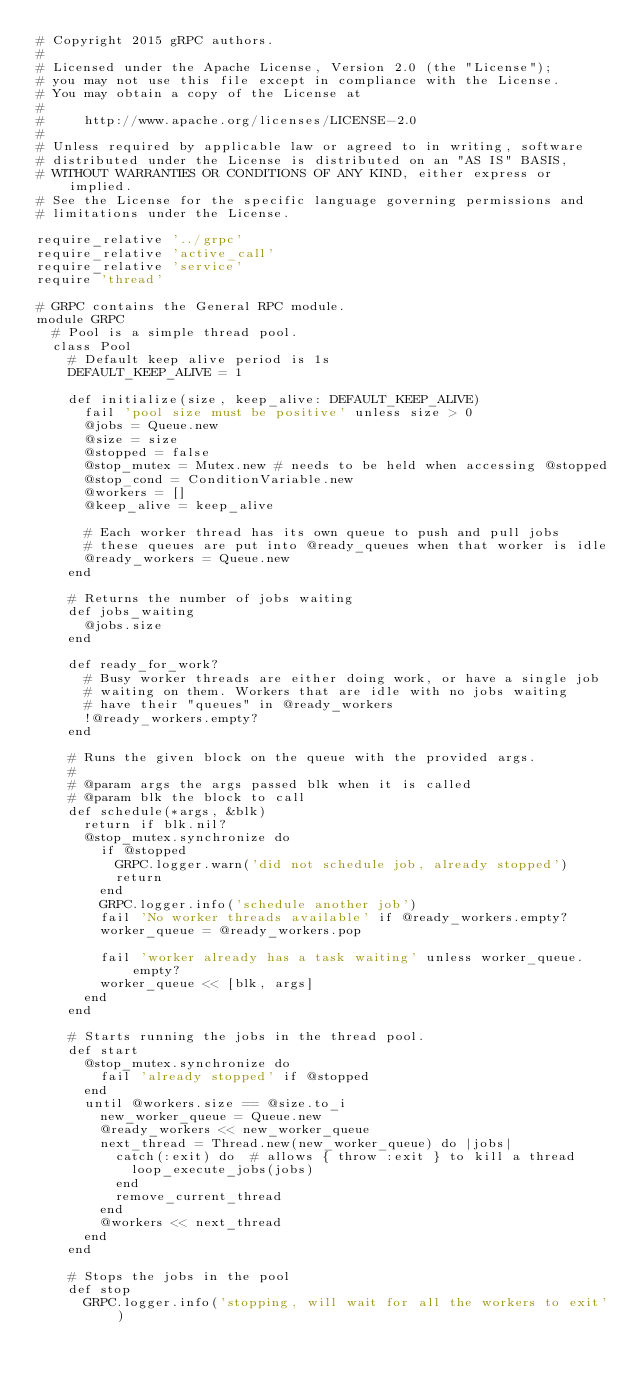<code> <loc_0><loc_0><loc_500><loc_500><_Ruby_># Copyright 2015 gRPC authors.
#
# Licensed under the Apache License, Version 2.0 (the "License");
# you may not use this file except in compliance with the License.
# You may obtain a copy of the License at
#
#     http://www.apache.org/licenses/LICENSE-2.0
#
# Unless required by applicable law or agreed to in writing, software
# distributed under the License is distributed on an "AS IS" BASIS,
# WITHOUT WARRANTIES OR CONDITIONS OF ANY KIND, either express or implied.
# See the License for the specific language governing permissions and
# limitations under the License.

require_relative '../grpc'
require_relative 'active_call'
require_relative 'service'
require 'thread'

# GRPC contains the General RPC module.
module GRPC
  # Pool is a simple thread pool.
  class Pool
    # Default keep alive period is 1s
    DEFAULT_KEEP_ALIVE = 1

    def initialize(size, keep_alive: DEFAULT_KEEP_ALIVE)
      fail 'pool size must be positive' unless size > 0
      @jobs = Queue.new
      @size = size
      @stopped = false
      @stop_mutex = Mutex.new # needs to be held when accessing @stopped
      @stop_cond = ConditionVariable.new
      @workers = []
      @keep_alive = keep_alive

      # Each worker thread has its own queue to push and pull jobs
      # these queues are put into @ready_queues when that worker is idle
      @ready_workers = Queue.new
    end

    # Returns the number of jobs waiting
    def jobs_waiting
      @jobs.size
    end

    def ready_for_work?
      # Busy worker threads are either doing work, or have a single job
      # waiting on them. Workers that are idle with no jobs waiting
      # have their "queues" in @ready_workers
      !@ready_workers.empty?
    end

    # Runs the given block on the queue with the provided args.
    #
    # @param args the args passed blk when it is called
    # @param blk the block to call
    def schedule(*args, &blk)
      return if blk.nil?
      @stop_mutex.synchronize do
        if @stopped
          GRPC.logger.warn('did not schedule job, already stopped')
          return
        end
        GRPC.logger.info('schedule another job')
        fail 'No worker threads available' if @ready_workers.empty?
        worker_queue = @ready_workers.pop

        fail 'worker already has a task waiting' unless worker_queue.empty?
        worker_queue << [blk, args]
      end
    end

    # Starts running the jobs in the thread pool.
    def start
      @stop_mutex.synchronize do
        fail 'already stopped' if @stopped
      end
      until @workers.size == @size.to_i
        new_worker_queue = Queue.new
        @ready_workers << new_worker_queue
        next_thread = Thread.new(new_worker_queue) do |jobs|
          catch(:exit) do  # allows { throw :exit } to kill a thread
            loop_execute_jobs(jobs)
          end
          remove_current_thread
        end
        @workers << next_thread
      end
    end

    # Stops the jobs in the pool
    def stop
      GRPC.logger.info('stopping, will wait for all the workers to exit')</code> 